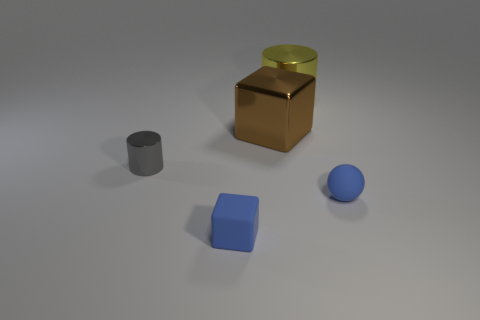Add 1 brown cylinders. How many objects exist? 6 Subtract all cylinders. How many objects are left? 3 Subtract 1 cylinders. How many cylinders are left? 1 Subtract all cyan spheres. Subtract all red cubes. How many spheres are left? 1 Subtract all large matte things. Subtract all tiny metal cylinders. How many objects are left? 4 Add 4 gray cylinders. How many gray cylinders are left? 5 Add 1 big green metal spheres. How many big green metal spheres exist? 1 Subtract 0 yellow spheres. How many objects are left? 5 